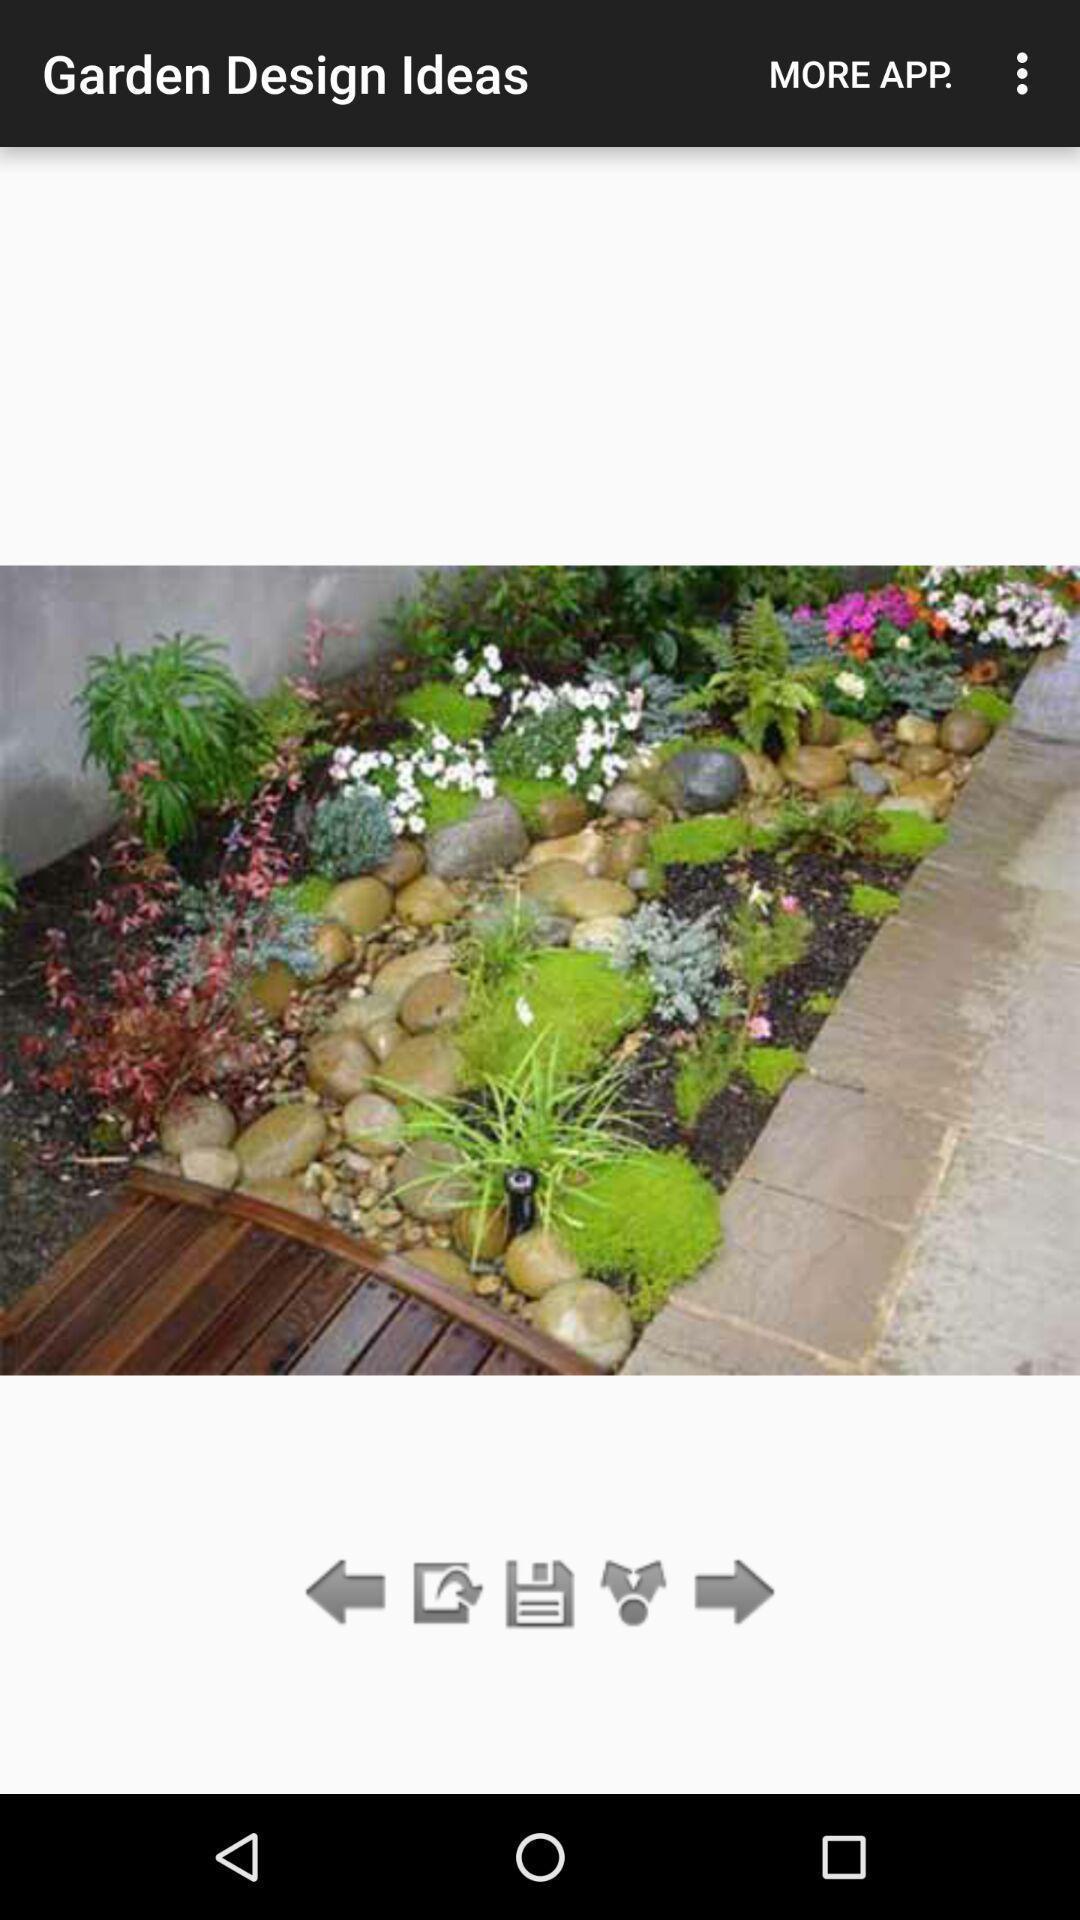Provide a detailed account of this screenshot. Screen displaying picture of a garden design ideas. 